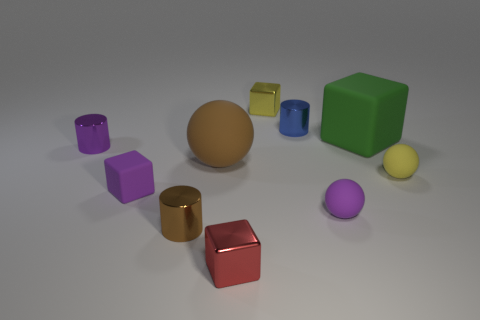Imagine these objects were part of a game, how might the game be played? Envisioning these objects as pieces in a game, one might associate different point values with each color or shape. Players could take turns rolling a dice and moving a chosen object towards the center, aiming to create a line of three with similarly shaped or colored objects to score points. 